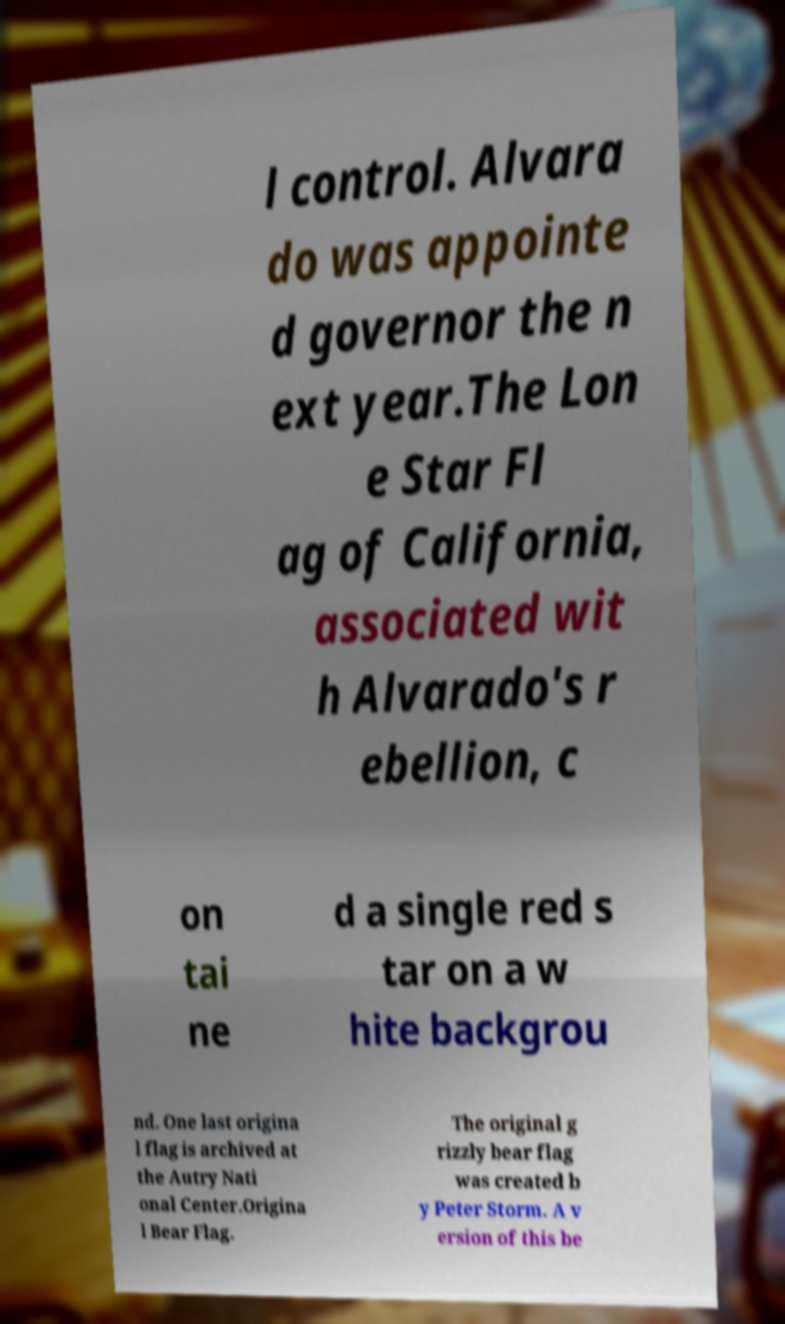Please identify and transcribe the text found in this image. l control. Alvara do was appointe d governor the n ext year.The Lon e Star Fl ag of California, associated wit h Alvarado's r ebellion, c on tai ne d a single red s tar on a w hite backgrou nd. One last origina l flag is archived at the Autry Nati onal Center.Origina l Bear Flag. The original g rizzly bear flag was created b y Peter Storm. A v ersion of this be 